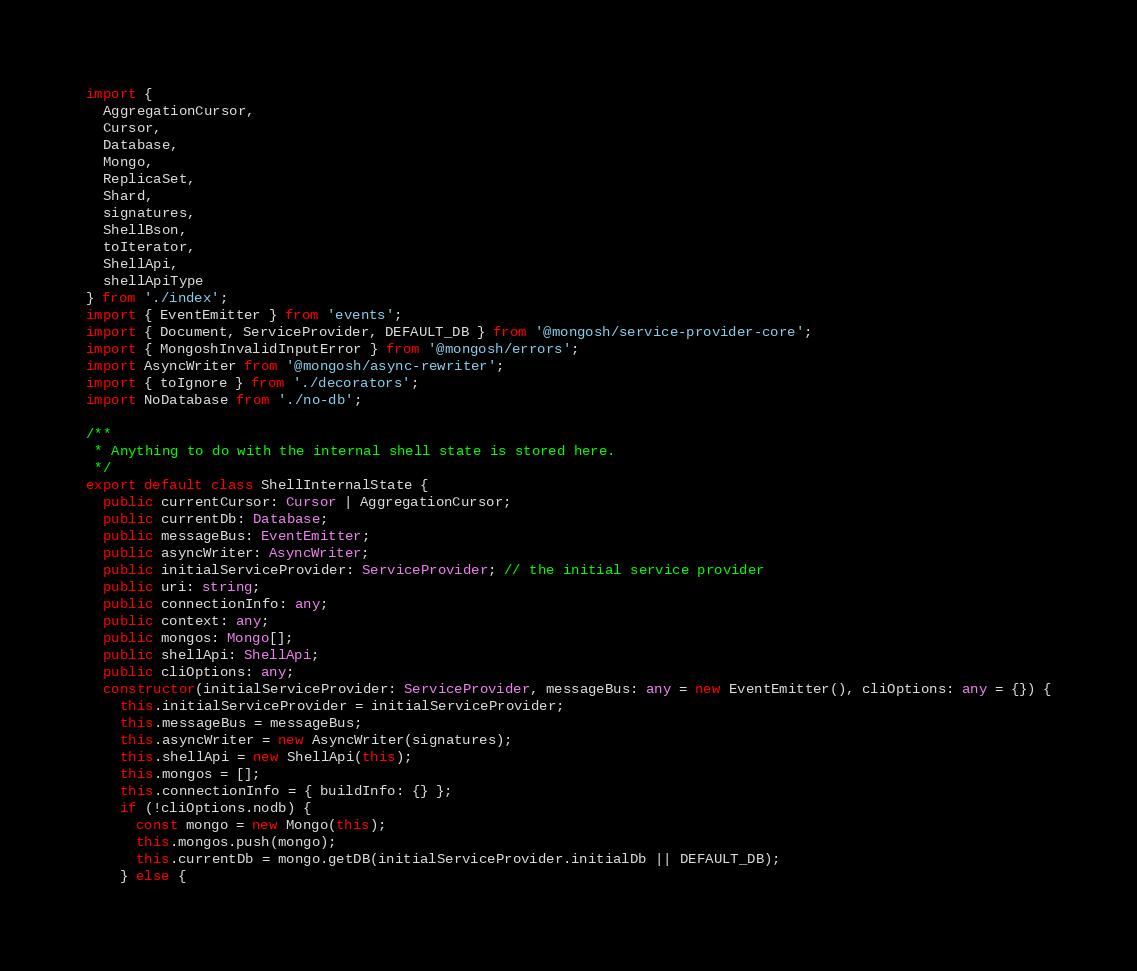<code> <loc_0><loc_0><loc_500><loc_500><_TypeScript_>import {
  AggregationCursor,
  Cursor,
  Database,
  Mongo,
  ReplicaSet,
  Shard,
  signatures,
  ShellBson,
  toIterator,
  ShellApi,
  shellApiType
} from './index';
import { EventEmitter } from 'events';
import { Document, ServiceProvider, DEFAULT_DB } from '@mongosh/service-provider-core';
import { MongoshInvalidInputError } from '@mongosh/errors';
import AsyncWriter from '@mongosh/async-rewriter';
import { toIgnore } from './decorators';
import NoDatabase from './no-db';

/**
 * Anything to do with the internal shell state is stored here.
 */
export default class ShellInternalState {
  public currentCursor: Cursor | AggregationCursor;
  public currentDb: Database;
  public messageBus: EventEmitter;
  public asyncWriter: AsyncWriter;
  public initialServiceProvider: ServiceProvider; // the initial service provider
  public uri: string;
  public connectionInfo: any;
  public context: any;
  public mongos: Mongo[];
  public shellApi: ShellApi;
  public cliOptions: any;
  constructor(initialServiceProvider: ServiceProvider, messageBus: any = new EventEmitter(), cliOptions: any = {}) {
    this.initialServiceProvider = initialServiceProvider;
    this.messageBus = messageBus;
    this.asyncWriter = new AsyncWriter(signatures);
    this.shellApi = new ShellApi(this);
    this.mongos = [];
    this.connectionInfo = { buildInfo: {} };
    if (!cliOptions.nodb) {
      const mongo = new Mongo(this);
      this.mongos.push(mongo);
      this.currentDb = mongo.getDB(initialServiceProvider.initialDb || DEFAULT_DB);
    } else {</code> 